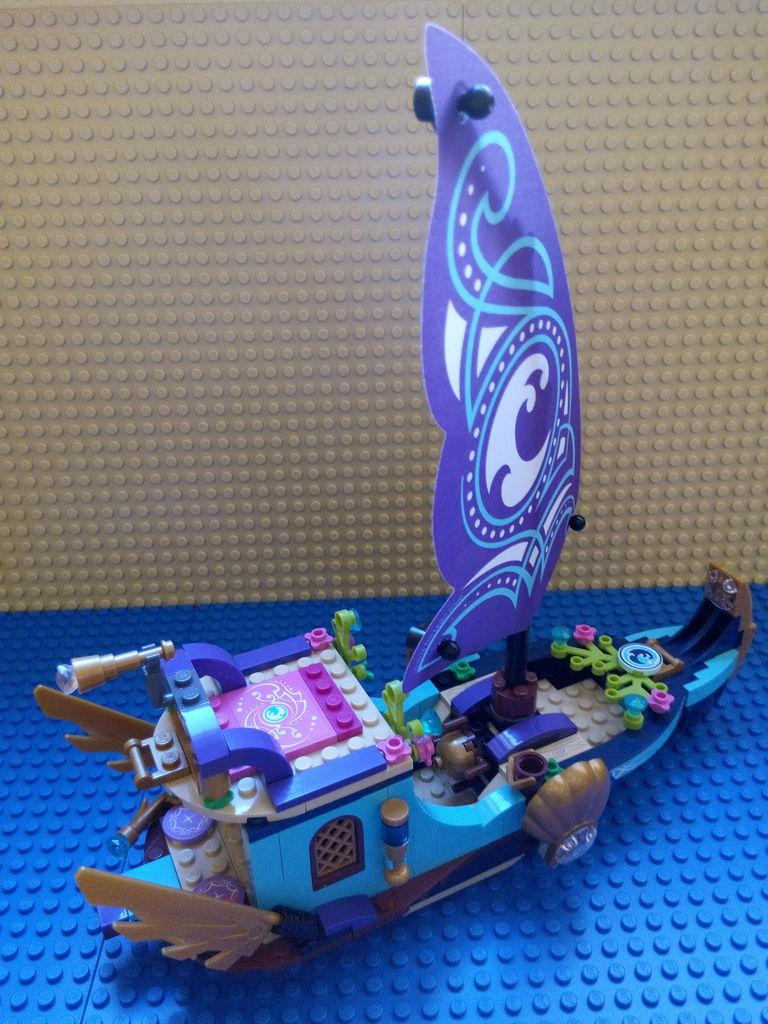What type of toy is featured in the image? There is Lego and a toy boat in the image. Are there any other toys visible in the image? Yes, there are other toys visible in the image. What type of drink is being served in the image? There is no drink present in the image; it features toys, including Lego and a toy boat. What type of educational material is visible in the image? There is no educational material present in the image; it features toys, including Lego and a toy boat. 